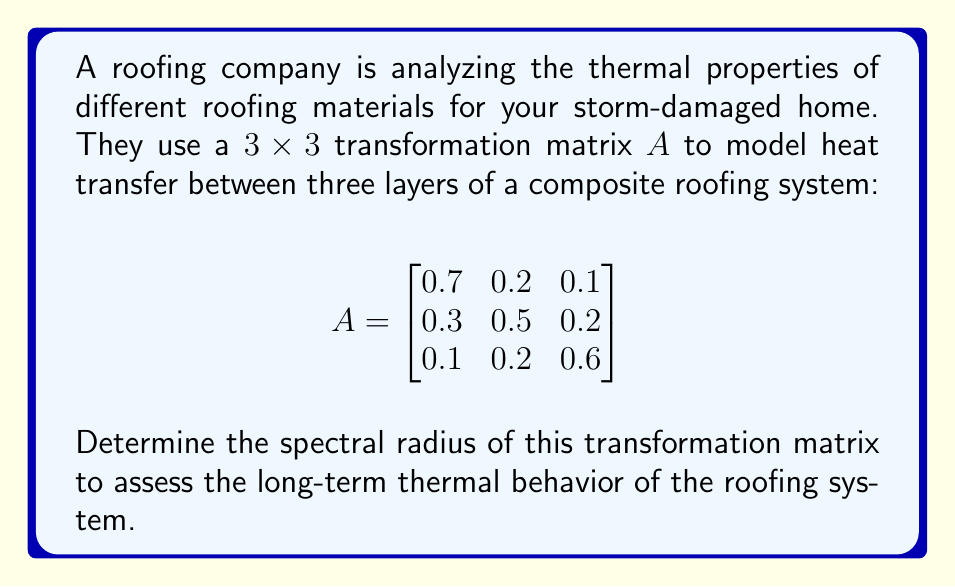Solve this math problem. To find the spectral radius of matrix $A$, we need to:

1) Find the eigenvalues of $A$
2) Take the absolute value of each eigenvalue
3) The spectral radius is the maximum of these absolute values

Step 1: Find the eigenvalues
The characteristic equation is $\det(A - \lambda I) = 0$

$$\det\begin{bmatrix}
0.7-\lambda & 0.2 & 0.1 \\
0.3 & 0.5-\lambda & 0.2 \\
0.1 & 0.2 & 0.6-\lambda
\end{bmatrix} = 0$$

Expanding this determinant:

$$(0.7-\lambda)(0.5-\lambda)(0.6-\lambda) - 0.2 \cdot 0.2 \cdot 0.1 - 0.1 \cdot 0.3 \cdot 0.2 \\ - (0.7-\lambda) \cdot 0.2 \cdot 0.2 - 0.3 \cdot 0.1 \cdot (0.6-\lambda) - 0.1 \cdot (0.5-\lambda) \cdot 0.2 = 0$$

Simplifying:

$$-\lambda^3 + 1.8\lambda^2 - 0.97\lambda + 0.16 = 0$$

Using a numerical method or computer algebra system, we find the roots:

$\lambda_1 \approx 1$, $\lambda_2 \approx 0.5$, $\lambda_3 \approx 0.3$

Step 2: Take absolute values
$|\lambda_1| \approx 1$, $|\lambda_2| \approx 0.5$, $|\lambda_3| \approx 0.3$

Step 3: Find the maximum
The spectral radius is the maximum of these values, which is 1.
Answer: 1 